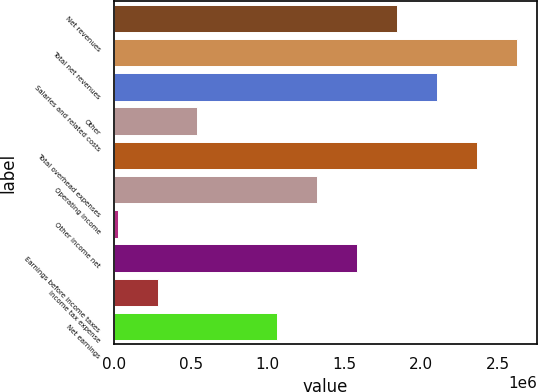Convert chart. <chart><loc_0><loc_0><loc_500><loc_500><bar_chart><fcel>Net revenues<fcel>Total net revenues<fcel>Salaries and related costs<fcel>Other<fcel>Total overhead expenses<fcel>Operating income<fcel>Other income net<fcel>Earnings before income taxes<fcel>Income tax expense<fcel>Net earnings<nl><fcel>1.84079e+06<fcel>2.62037e+06<fcel>2.10065e+06<fcel>541487<fcel>2.36051e+06<fcel>1.32107e+06<fcel>21766<fcel>1.58093e+06<fcel>281627<fcel>1.06121e+06<nl></chart> 